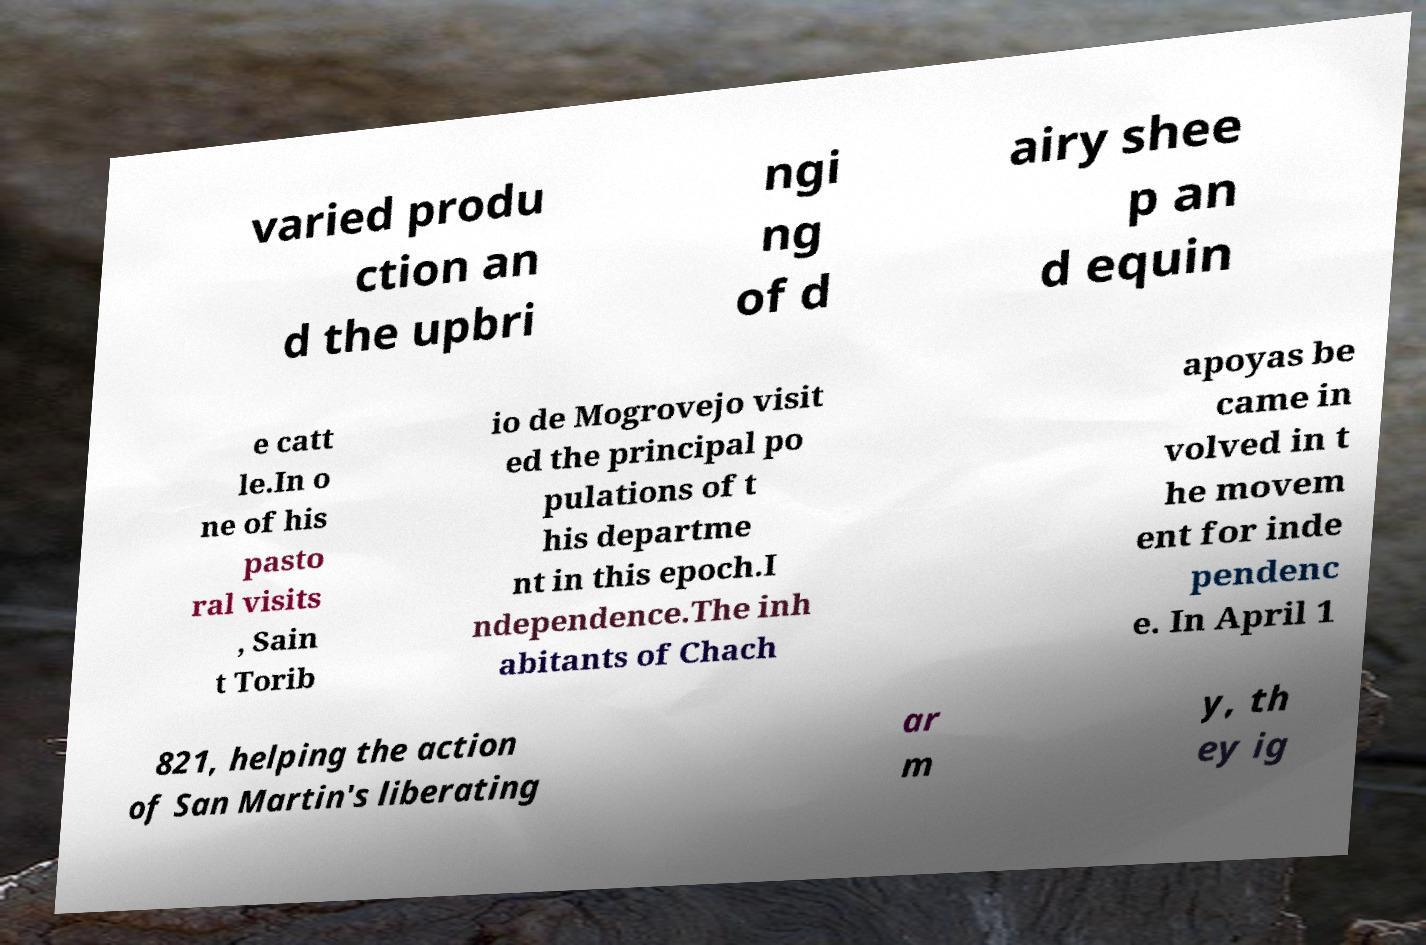Please read and relay the text visible in this image. What does it say? varied produ ction an d the upbri ngi ng of d airy shee p an d equin e catt le.In o ne of his pasto ral visits , Sain t Torib io de Mogrovejo visit ed the principal po pulations of t his departme nt in this epoch.I ndependence.The inh abitants of Chach apoyas be came in volved in t he movem ent for inde pendenc e. In April 1 821, helping the action of San Martin's liberating ar m y, th ey ig 